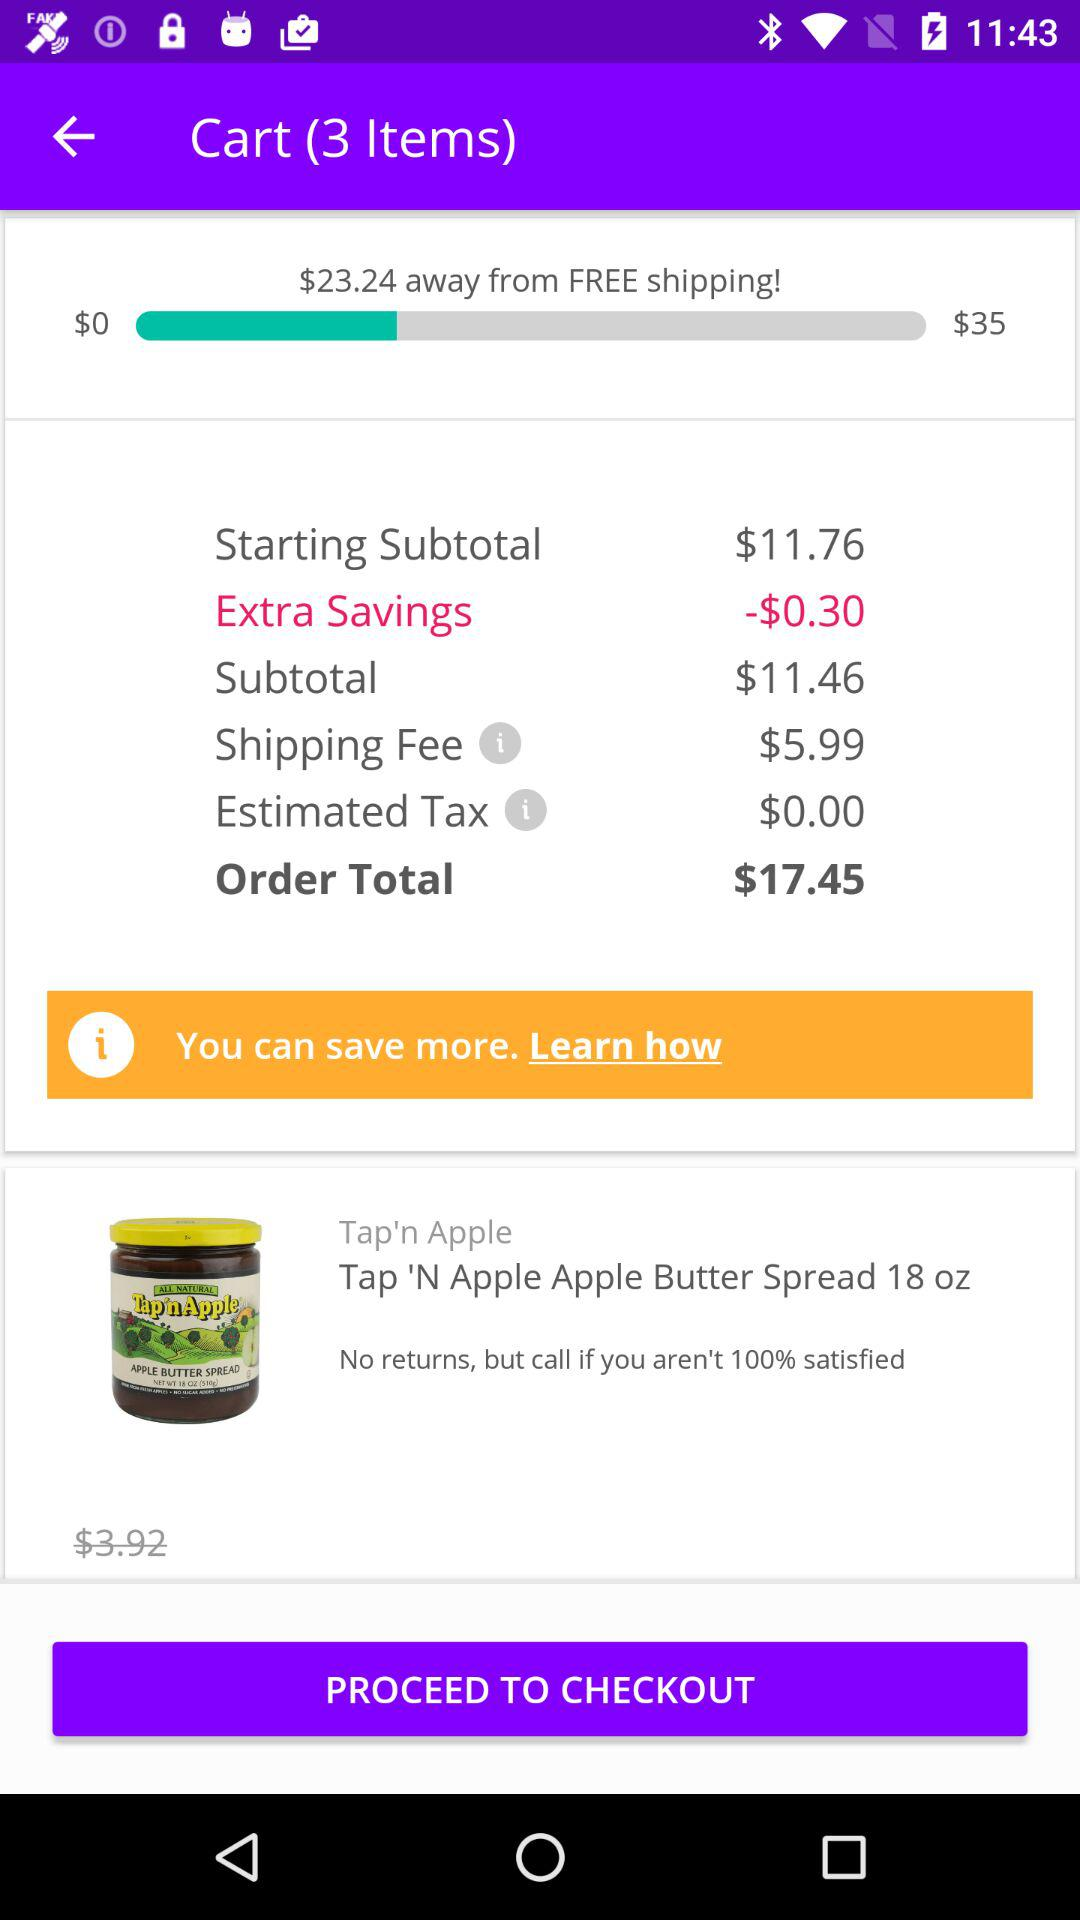What is the order total? The order total is $17.45. 